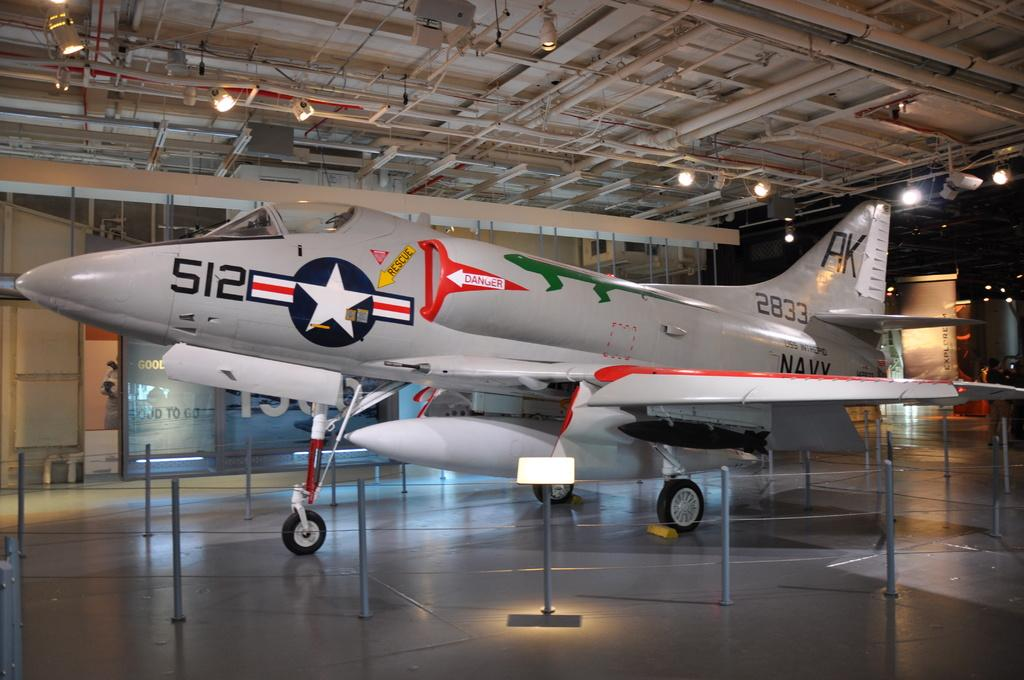<image>
Offer a succinct explanation of the picture presented. a plane in a museum with letters AK on the tail 